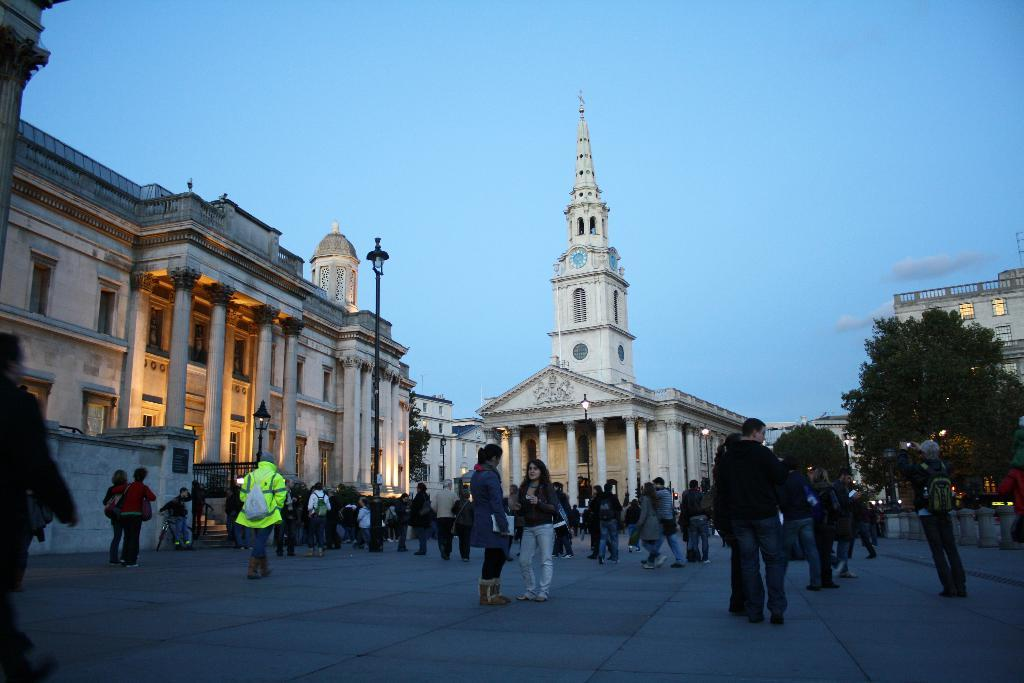What can be seen in the foreground of the image? There are people and trees in the foreground of the image. What is visible in the background of the image? Buildings, pillars, a clock tower, a metal gate, a pole, and the sky are visible in the background of the image. Can you tell me how many pigs are depicted in the image? There are no pigs present in the image. What type of kettle is hanging from the clock tower in the image? There is no kettle present in the image, and the clock tower does not have any kettles hanging from it. 